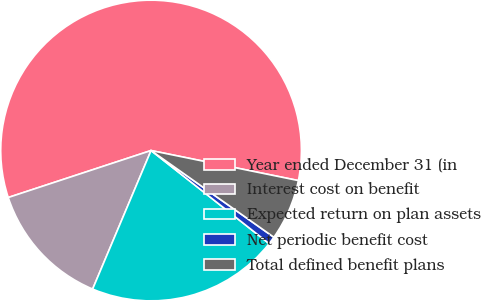Convert chart. <chart><loc_0><loc_0><loc_500><loc_500><pie_chart><fcel>Year ended December 31 (in<fcel>Interest cost on benefit<fcel>Expected return on plan assets<fcel>Net periodic benefit cost<fcel>Total defined benefit plans<nl><fcel>58.26%<fcel>13.59%<fcel>20.73%<fcel>0.84%<fcel>6.58%<nl></chart> 